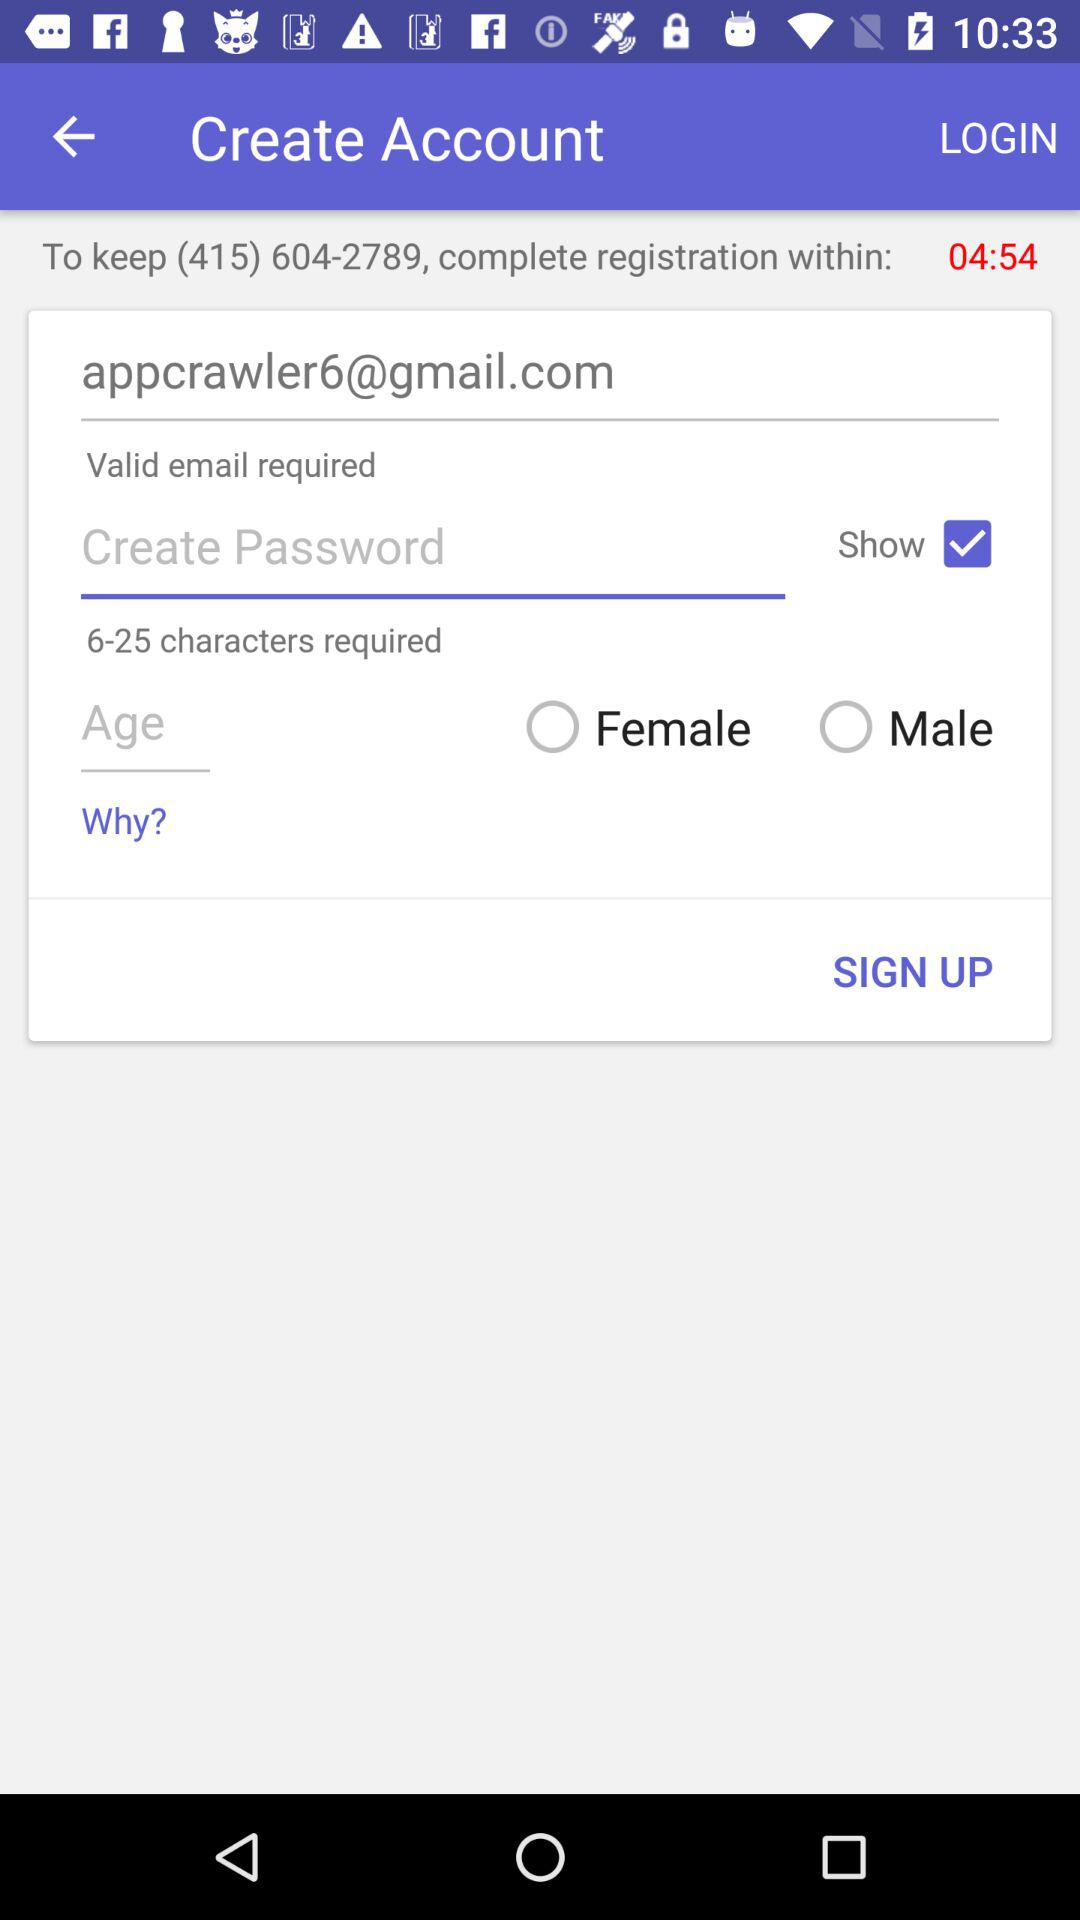What is the registration number?
When the provided information is insufficient, respond with <no answer>. <no answer> 